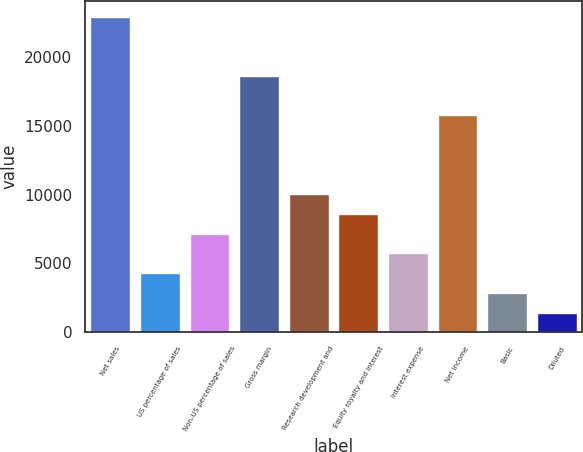Convert chart. <chart><loc_0><loc_0><loc_500><loc_500><bar_chart><fcel>Net sales<fcel>US percentage of sales<fcel>Non-US percentage of sales<fcel>Gross margin<fcel>Research development and<fcel>Equity royalty and interest<fcel>Interest expense<fcel>Net income<fcel>Basic<fcel>Diluted<nl><fcel>22946.8<fcel>4303.02<fcel>7171.3<fcel>18644.4<fcel>10039.6<fcel>8605.44<fcel>5737.16<fcel>15776.1<fcel>2868.88<fcel>1434.74<nl></chart> 